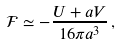<formula> <loc_0><loc_0><loc_500><loc_500>\mathcal { F } \simeq - \frac { U + a V } { 1 6 \pi a ^ { 3 } } \, ,</formula> 